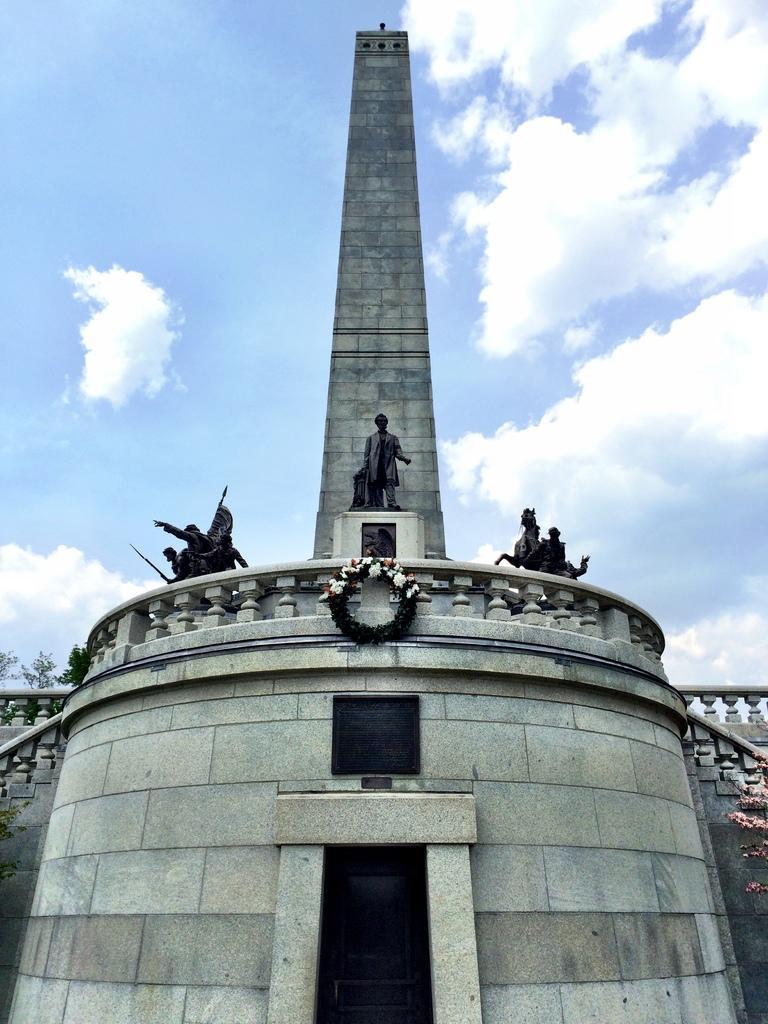Can you describe this image briefly? In this image I can see the building, few statues of people and animals. In front I can see the garland to the building and I can see the sky. 